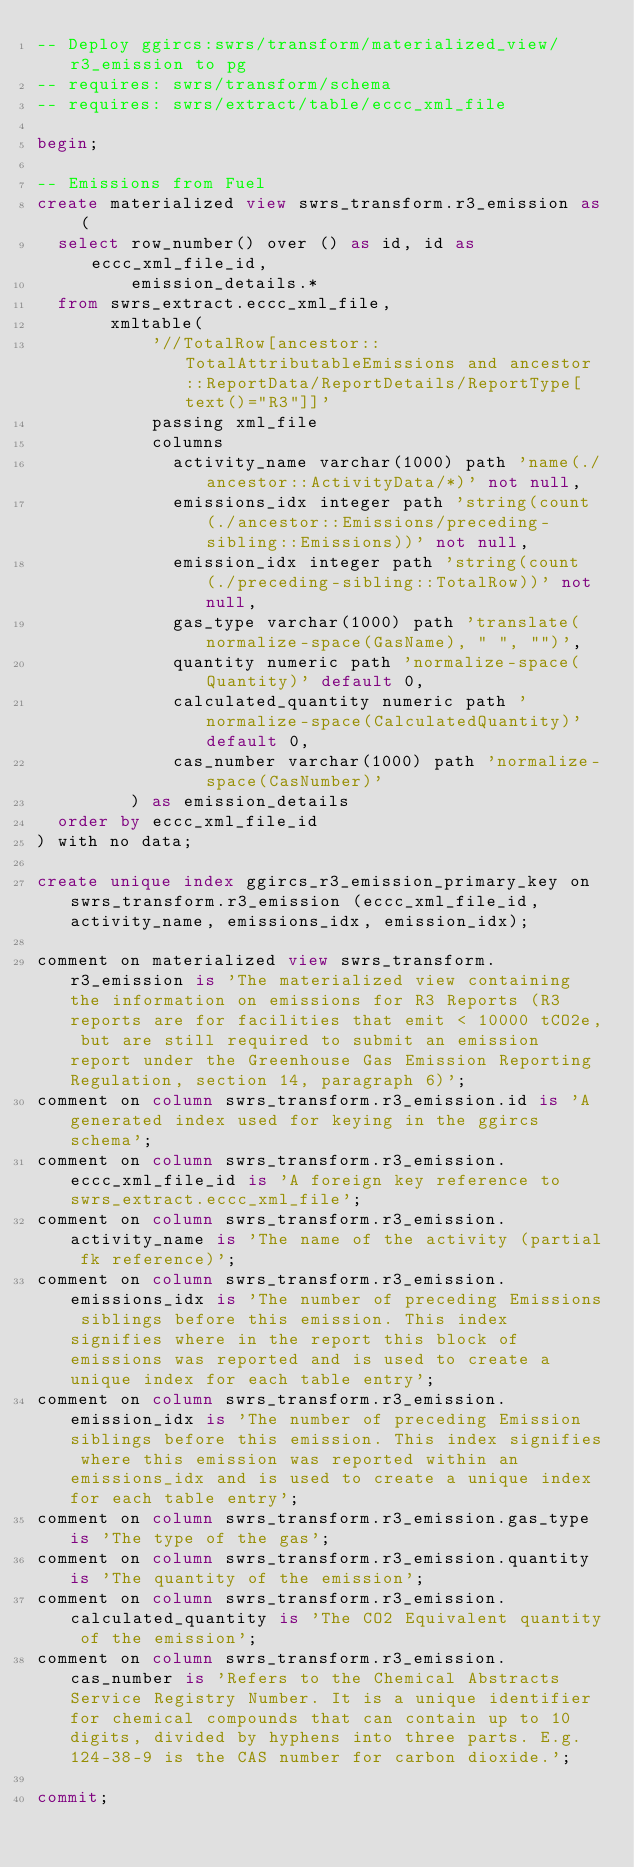Convert code to text. <code><loc_0><loc_0><loc_500><loc_500><_SQL_>-- Deploy ggircs:swrs/transform/materialized_view/r3_emission to pg
-- requires: swrs/transform/schema
-- requires: swrs/extract/table/eccc_xml_file

begin;

-- Emissions from Fuel
create materialized view swrs_transform.r3_emission as (
  select row_number() over () as id, id as eccc_xml_file_id,
         emission_details.*
  from swrs_extract.eccc_xml_file,
       xmltable(
           '//TotalRow[ancestor::TotalAttributableEmissions and ancestor::ReportData/ReportDetails/ReportType[text()="R3"]]'
           passing xml_file
           columns
             activity_name varchar(1000) path 'name(./ancestor::ActivityData/*)' not null,
             emissions_idx integer path 'string(count(./ancestor::Emissions/preceding-sibling::Emissions))' not null,
             emission_idx integer path 'string(count(./preceding-sibling::TotalRow))' not null,
             gas_type varchar(1000) path 'translate(normalize-space(GasName), " ", "")',
             quantity numeric path 'normalize-space(Quantity)' default 0,
             calculated_quantity numeric path 'normalize-space(CalculatedQuantity)' default 0,
             cas_number varchar(1000) path 'normalize-space(CasNumber)'
         ) as emission_details
  order by eccc_xml_file_id
) with no data;

create unique index ggircs_r3_emission_primary_key on swrs_transform.r3_emission (eccc_xml_file_id, activity_name, emissions_idx, emission_idx);

comment on materialized view swrs_transform.r3_emission is 'The materialized view containing the information on emissions for R3 Reports (R3 reports are for facilities that emit < 10000 tCO2e, but are still required to submit an emission report under the Greenhouse Gas Emission Reporting Regulation, section 14, paragraph 6)';
comment on column swrs_transform.r3_emission.id is 'A generated index used for keying in the ggircs schema';
comment on column swrs_transform.r3_emission.eccc_xml_file_id is 'A foreign key reference to swrs_extract.eccc_xml_file';
comment on column swrs_transform.r3_emission.activity_name is 'The name of the activity (partial fk reference)';
comment on column swrs_transform.r3_emission.emissions_idx is 'The number of preceding Emissions siblings before this emission. This index signifies where in the report this block of emissions was reported and is used to create a unique index for each table entry';
comment on column swrs_transform.r3_emission.emission_idx is 'The number of preceding Emission siblings before this emission. This index signifies where this emission was reported within an emissions_idx and is used to create a unique index for each table entry';
comment on column swrs_transform.r3_emission.gas_type is 'The type of the gas';
comment on column swrs_transform.r3_emission.quantity is 'The quantity of the emission';
comment on column swrs_transform.r3_emission.calculated_quantity is 'The CO2 Equivalent quantity of the emission';
comment on column swrs_transform.r3_emission.cas_number is 'Refers to the Chemical Abstracts Service Registry Number. It is a unique identifier for chemical compounds that can contain up to 10 digits, divided by hyphens into three parts. E.g. 124-38-9 is the CAS number for carbon dioxide.';

commit;
</code> 